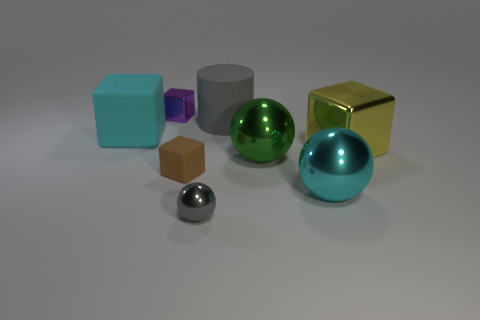Is there any other thing that has the same size as the brown matte object?
Offer a very short reply. Yes. There is a big cyan metallic object; what number of tiny brown blocks are left of it?
Keep it short and to the point. 1. There is a object in front of the big cyan thing that is on the right side of the small purple cube; what shape is it?
Offer a very short reply. Sphere. Are there any other things that are the same shape as the gray matte object?
Your response must be concise. No. Is the number of large cyan things that are in front of the large yellow shiny cube greater than the number of tiny brown shiny cubes?
Offer a terse response. Yes. How many big yellow things are in front of the big cyan thing that is to the right of the brown thing?
Provide a short and direct response. 0. What shape is the metal thing that is to the right of the big cyan object that is to the right of the large cylinder behind the big yellow shiny thing?
Provide a succinct answer. Cube. What is the size of the gray shiny sphere?
Offer a terse response. Small. Are there any other large things made of the same material as the yellow object?
Your answer should be very brief. Yes. There is a gray metal thing that is the same shape as the big green object; what is its size?
Your response must be concise. Small. 